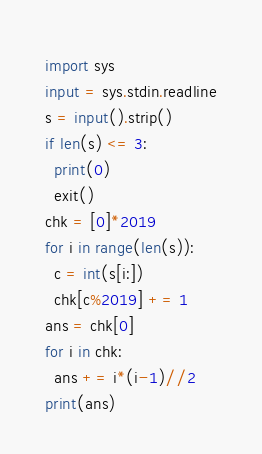Convert code to text. <code><loc_0><loc_0><loc_500><loc_500><_Python_>import sys
input = sys.stdin.readline
s = input().strip()
if len(s) <= 3:
  print(0)
  exit()
chk = [0]*2019
for i in range(len(s)):
  c = int(s[i:])
  chk[c%2019] += 1
ans = chk[0]
for i in chk:
  ans += i*(i-1)//2
print(ans)</code> 